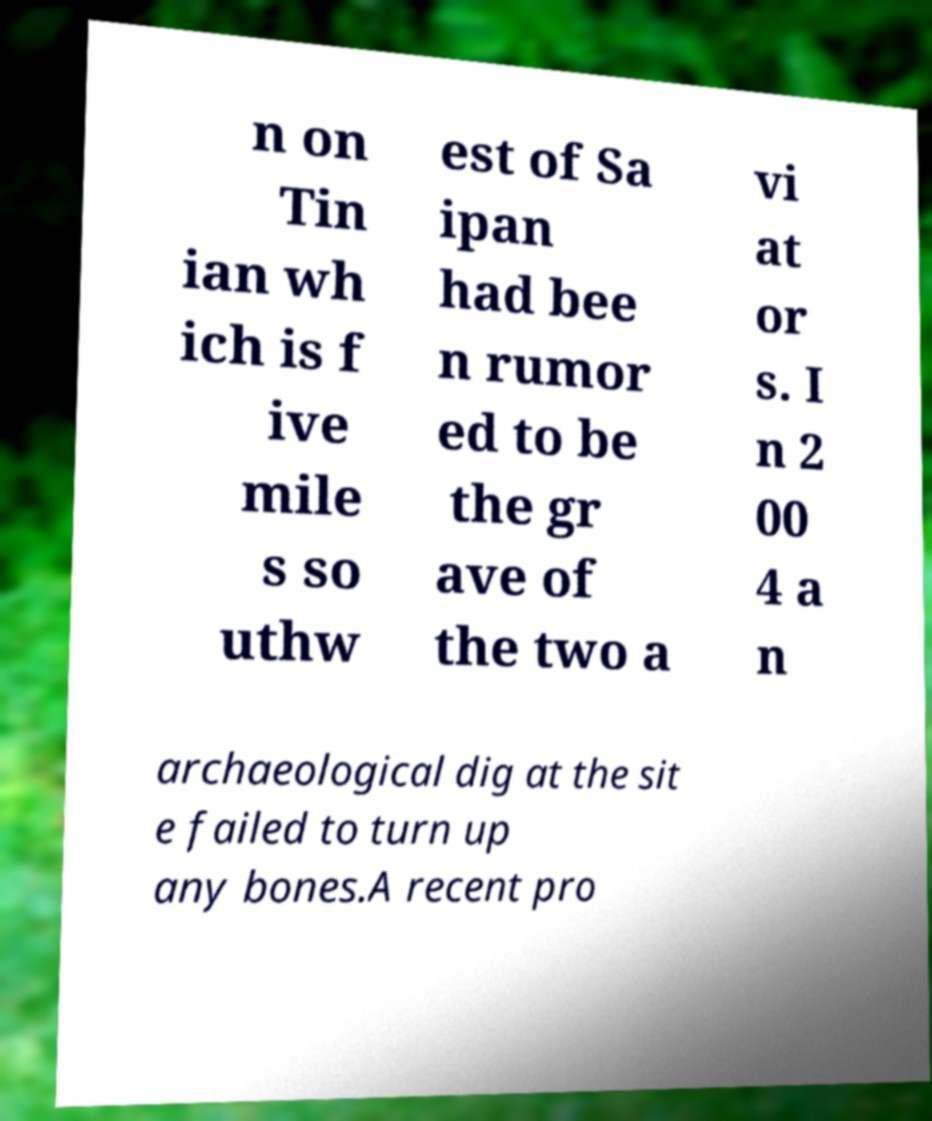Can you read and provide the text displayed in the image?This photo seems to have some interesting text. Can you extract and type it out for me? n on Tin ian wh ich is f ive mile s so uthw est of Sa ipan had bee n rumor ed to be the gr ave of the two a vi at or s. I n 2 00 4 a n archaeological dig at the sit e failed to turn up any bones.A recent pro 